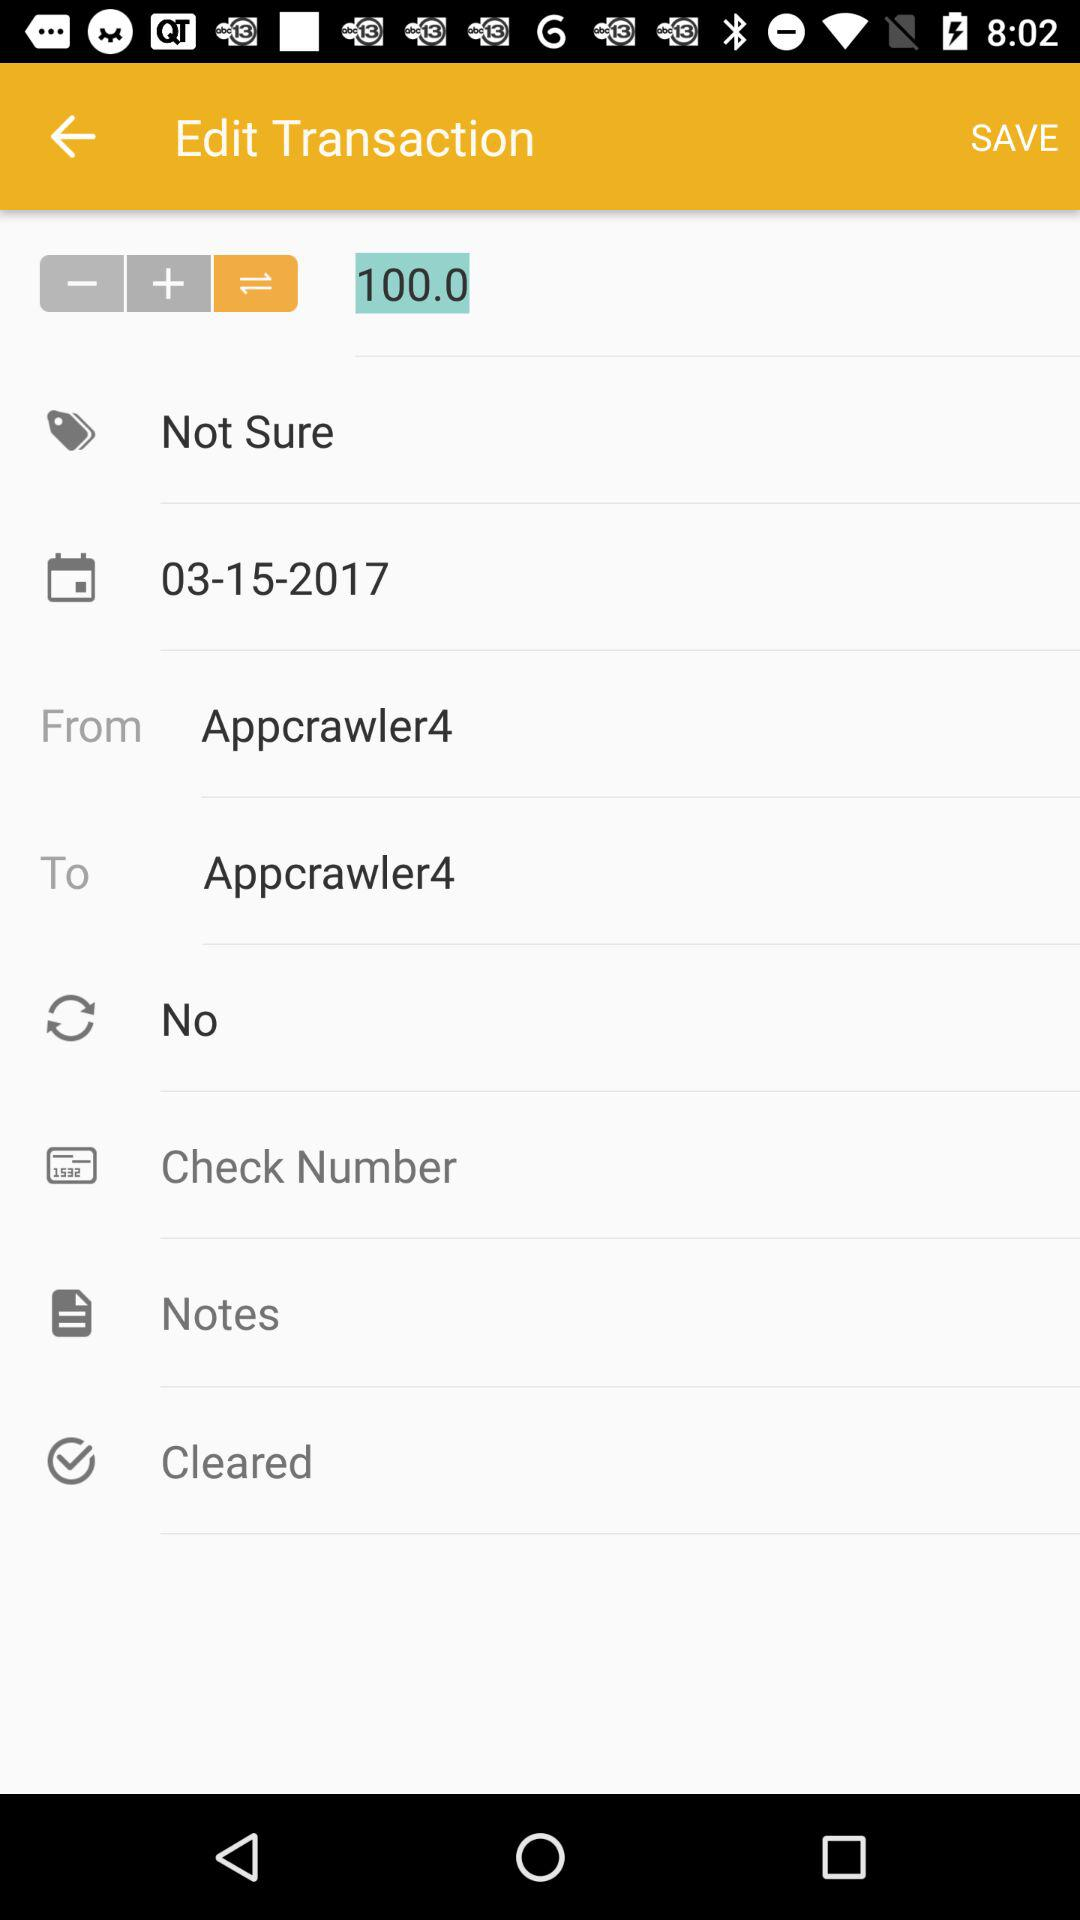What is the date of the transaction?
Answer the question using a single word or phrase. 03-15-2017 